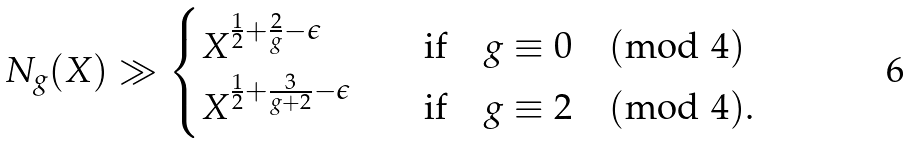<formula> <loc_0><loc_0><loc_500><loc_500>N _ { g } ( X ) \gg \begin{cases} X ^ { \frac { 1 } { 2 } + \frac { 2 } { g } - \epsilon } \quad & \text {if} \quad g \equiv 0 \pmod { 4 } \\ X ^ { \frac { 1 } { 2 } + \frac { 3 } { g + 2 } - \epsilon } \quad & \text {if} \quad g \equiv 2 \pmod { 4 } . \end{cases}</formula> 